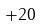Convert formula to latex. <formula><loc_0><loc_0><loc_500><loc_500>+ 2 0</formula> 